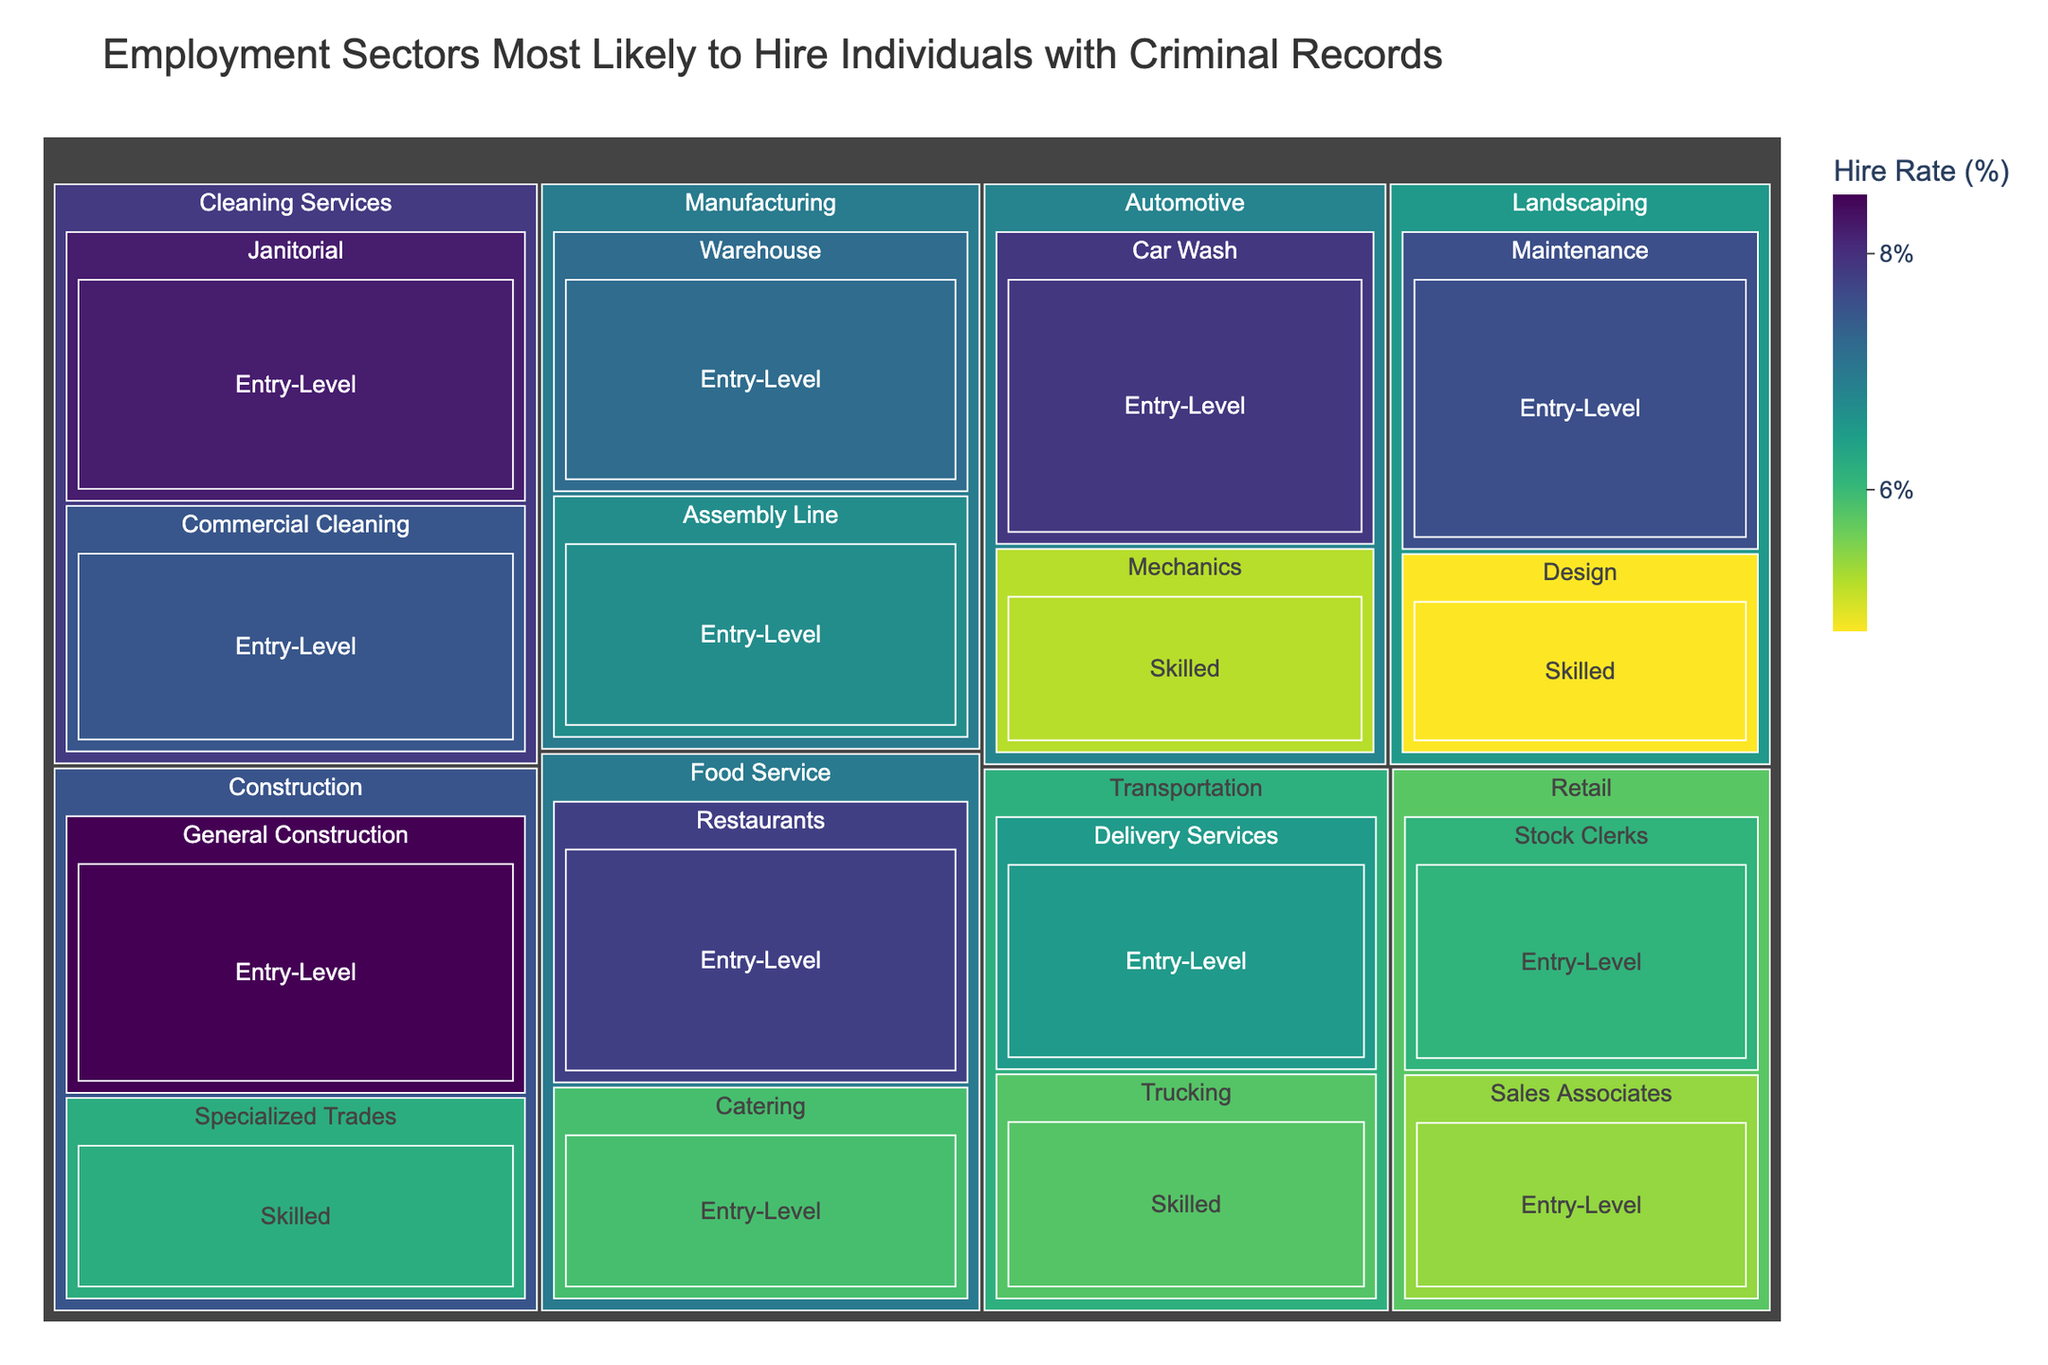What industry is the most likely to hire individuals with criminal records? The title of the treemap suggests that the hire rate is depicted by the size and color of each segment. In the treemap, "Construction" appears to have the largest segments with high hire rates.
Answer: Construction Which job level within the Food Service industry has the highest hire rate? By examining the segments under the Food Service industry, "Restaurants, Entry-Level" shows the highest hire rate.
Answer: Entry-Level Are there any industries where the hire rates for entry-level and skilled jobs can be compared directly? Industries such as Construction, Manufacturing, and Landscaping have both entry-level and skilled job segments, allowing for a direct comparison.
Answer: Construction, Manufacturing, Landscaping What is the average hire rate for entry-level positions across all industries? Summing the hire rates for all entry-level positions: (8.5 + 7.8 + 5.9 + 6.7 + 7.2 + 5.4 + 6.1 + 6.5 + 7.6 + 7.9 + 8.2 + 7.5) and dividing by the number of entry-level positions (12), we get: 85.3 / 12 = 7.11.
Answer: 7.11 Which sector within the Cleaning Services industry has the higher hire rate? By looking at the segments under the Cleaning Services industry, "Janitorial, Entry-Level" shows a higher hire rate compared to "Commercial Cleaning, Entry-Level".
Answer: Janitorial How does the hire rate of Automotive Mechanics compare to the hire rate of Trucking in the Transportation industry? Comparing the hire rates shown in the treemap, Automotive Mechanics (5.2%) has a lower hire rate than Trucking (5.8%).
Answer: Automotive Mechanics has a lower hire rate Is there a significant difference between the highest and lowest hire rates within the Entry-Level job level across all industries? The highest hire rate in Entry-Level segments is 8.5% (General Construction) and the lowest is 5.4% (Sales Associates in Retail). The difference is: 8.5 - 5.4 = 3.1
Answer: 3.1 What industries show hire rates for skilled jobs in the treemap? The industries with segments for skilled jobs are Construction, Transportation, Landscaping, and Automotive. These sectors include specialized trades, trucking, design, and mechanics.
Answer: Construction, Transportation, Landscaping, Automotive Which three sectors have hire rates closest to 6.5%? By examining the segments, the sectors closest to 6.5% are Trucking in Transportation (5.8%), Catering in Food Service (5.9%), and Stock Clerks in Retail (6.1%).
Answer: Trucking, Catering, Stock Clerks Which entry-level job within the Landscaping industry has a higher hire rate? The treemap shows that "Maintenance, Entry-Level" has a higher hire rate (7.6%) compared to "Design, Skilled" (4.8%).
Answer: Maintenance 